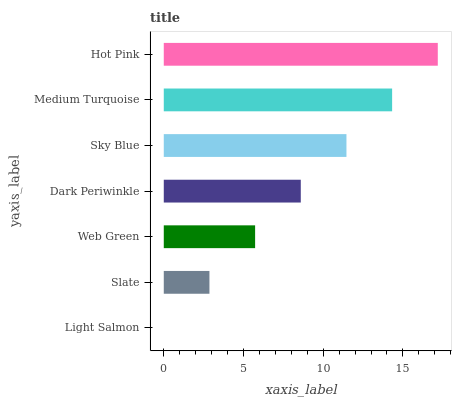Is Light Salmon the minimum?
Answer yes or no. Yes. Is Hot Pink the maximum?
Answer yes or no. Yes. Is Slate the minimum?
Answer yes or no. No. Is Slate the maximum?
Answer yes or no. No. Is Slate greater than Light Salmon?
Answer yes or no. Yes. Is Light Salmon less than Slate?
Answer yes or no. Yes. Is Light Salmon greater than Slate?
Answer yes or no. No. Is Slate less than Light Salmon?
Answer yes or no. No. Is Dark Periwinkle the high median?
Answer yes or no. Yes. Is Dark Periwinkle the low median?
Answer yes or no. Yes. Is Medium Turquoise the high median?
Answer yes or no. No. Is Medium Turquoise the low median?
Answer yes or no. No. 